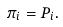<formula> <loc_0><loc_0><loc_500><loc_500>\pi _ { i } = P _ { i } .</formula> 